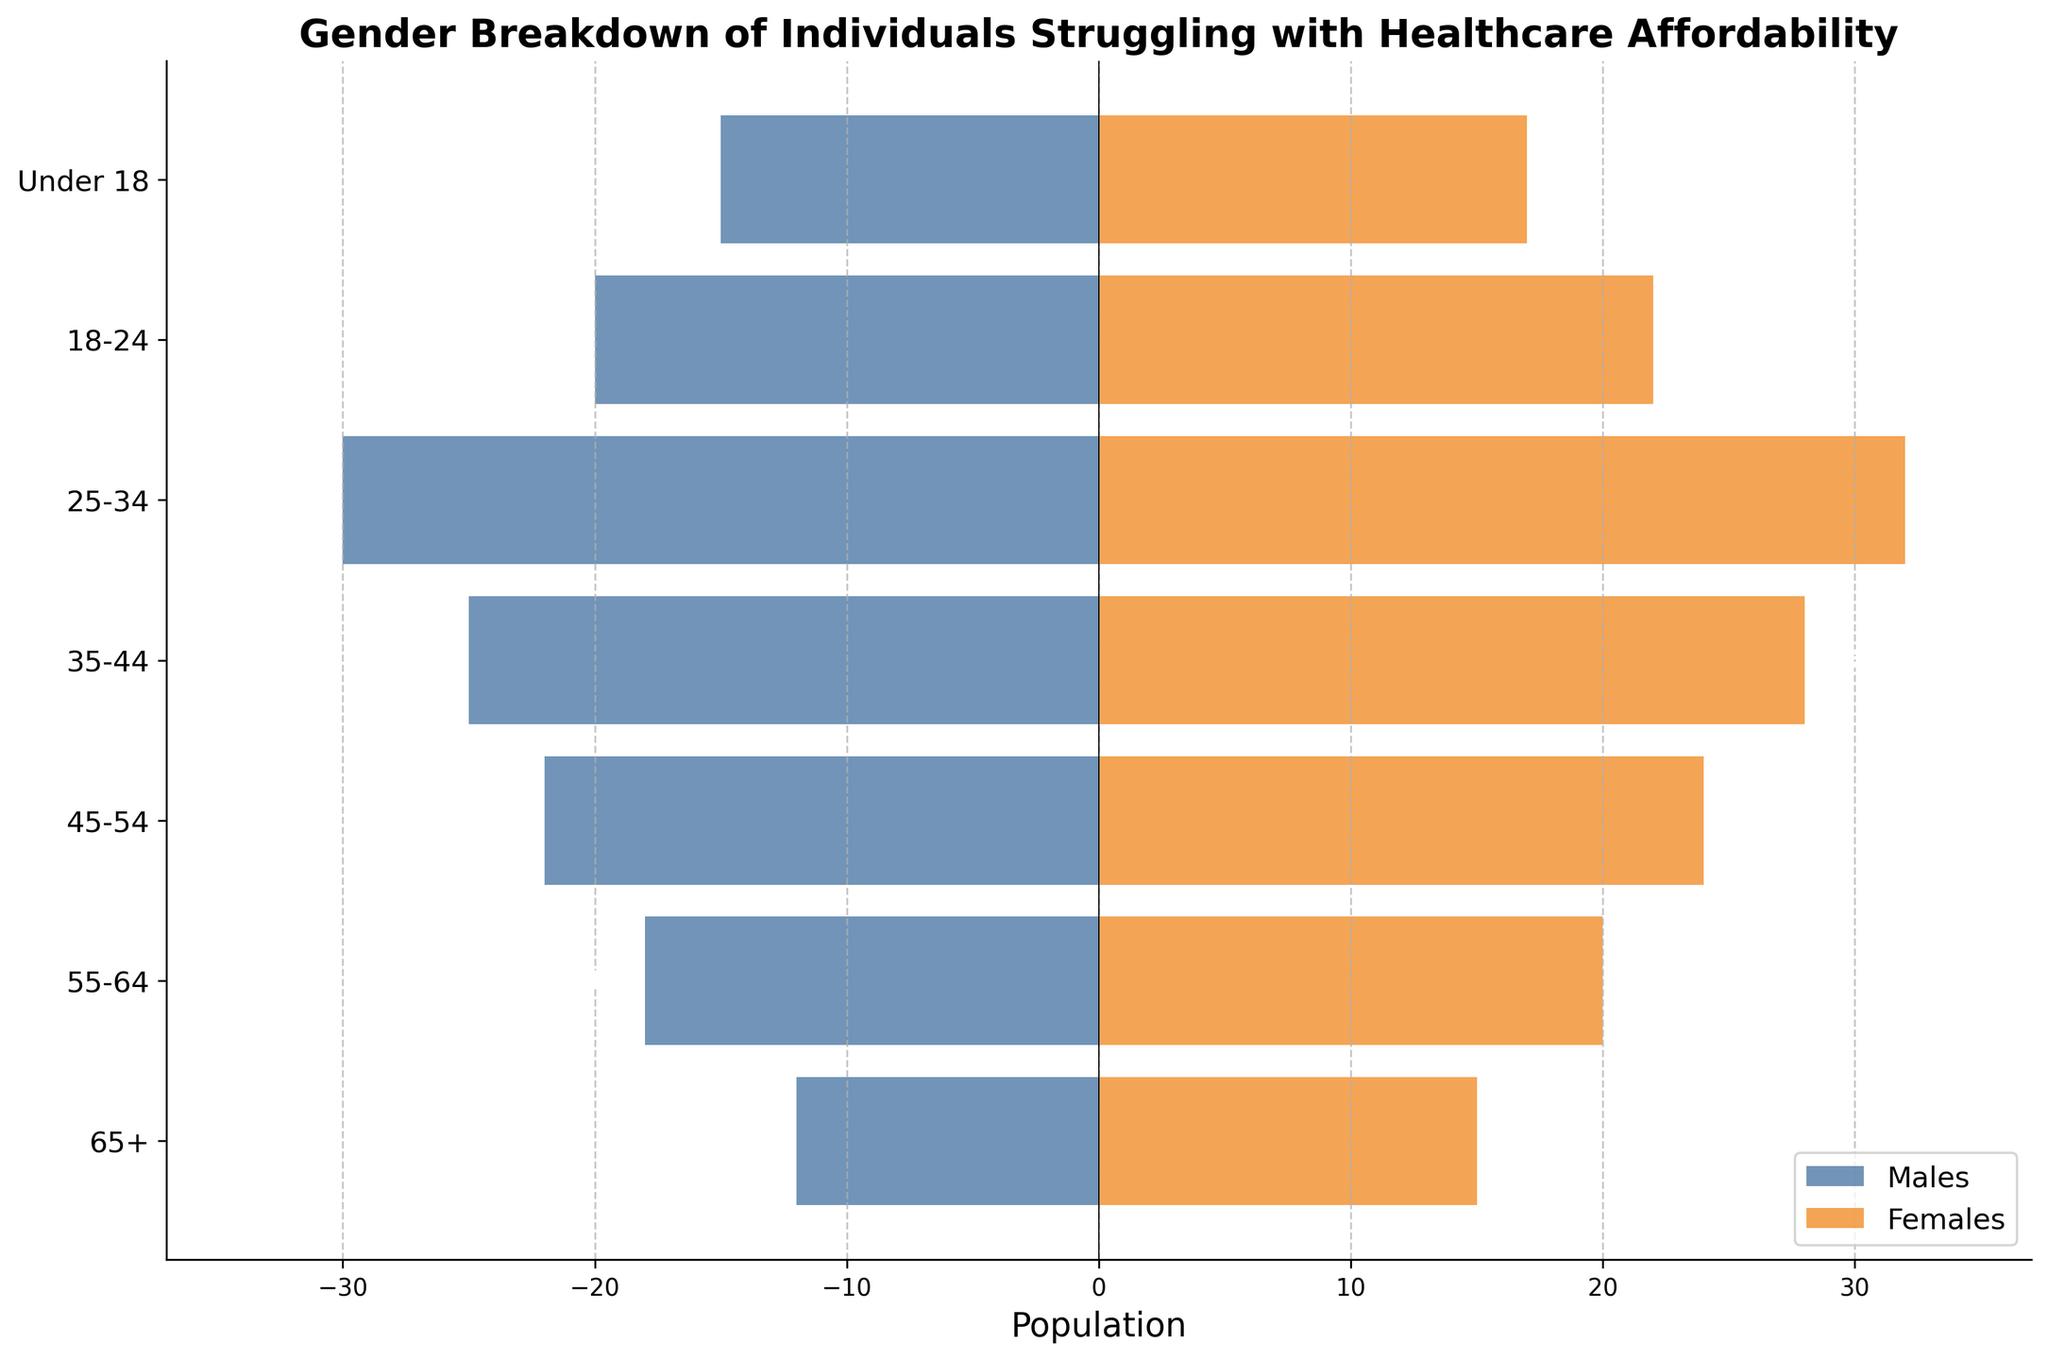What's the title of the figure? The title of the figure is given at the top center of the plot, which indicates what the figure is about.
Answer: Gender Breakdown of Individuals Struggling with Healthcare Affordability How many age groups are represented in the figure? By counting the number of different age group labels on the y-axis, we can determine the total number of age groups
Answer: 7 Which age group has the highest number of females struggling with healthcare affordability? Look at the bar lengths for each age group on the female side (the positive side). The longest bar represents the highest number.
Answer: 25-34 What's the difference in the number of males struggling with healthcare affordability between the age groups 45-54 and 55-64? Subtract the number of males in the 55-64 group from the number in the 45-54 group: 22 (45-54) - 18 (55-64)
Answer: 4 Which age group has more males struggling with healthcare affordability, 18-24 or Under 18? Compare the lengths of the bars for males in the 18-24 and Under 18 age groups. The longer bar represents the higher number.
Answer: 18-24 What is the total number of individuals (both males and females) under the age of 18 struggling with healthcare affordability? Add the number of males and females in the "Under 18" group: 15 (males) + 17 (females)
Answer: 32 For which age group is the difference in the number of struggling males and females the smallest? Calculate the absolute differences for each age group and compare them to find the smallest one: Under 18 (2), 18-24 (2), 25-34 (2), 35-44 (3), 45-54 (2), 55-64 (2), 65+ (3)
Answer: 18-24 (or 25-34 or 45-54 or 55-64; all have a difference of 2, tied) How many more females than males are there in the 35-44 age group struggling with healthcare affordability? Subtract the number of males from the number of females in the 35-44 age group: 28 (females) - 25 (males)
Answer: 3 Which age group has the smallest number of males struggling with healthcare affordability? Identify the shortest bar on the male side (the negative side) of the plot.
Answer: 65+ 